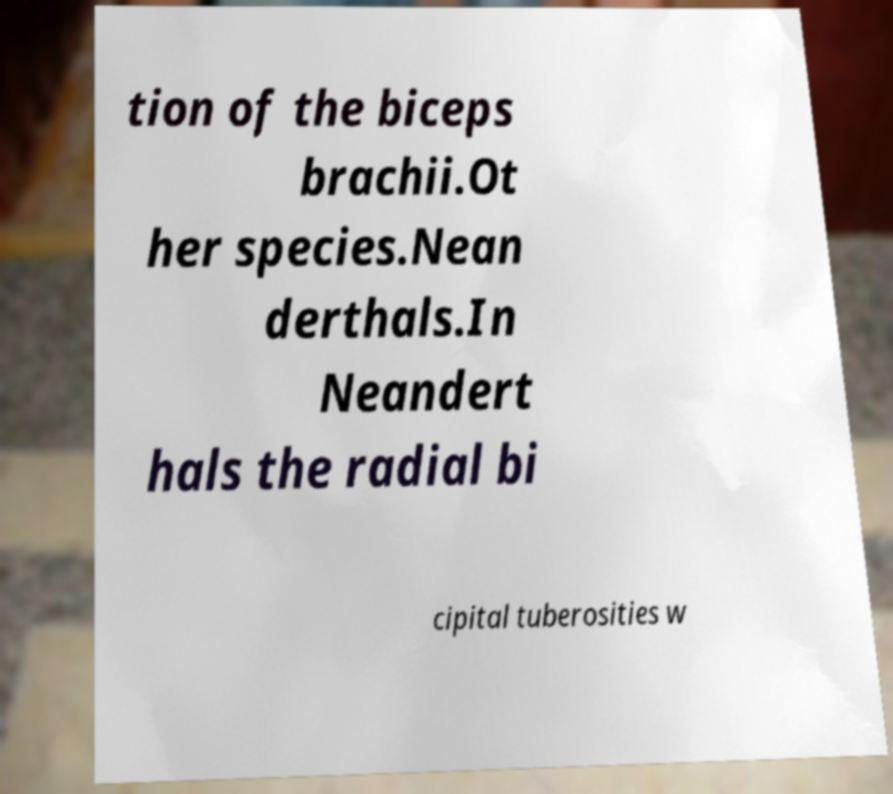Please read and relay the text visible in this image. What does it say? tion of the biceps brachii.Ot her species.Nean derthals.In Neandert hals the radial bi cipital tuberosities w 